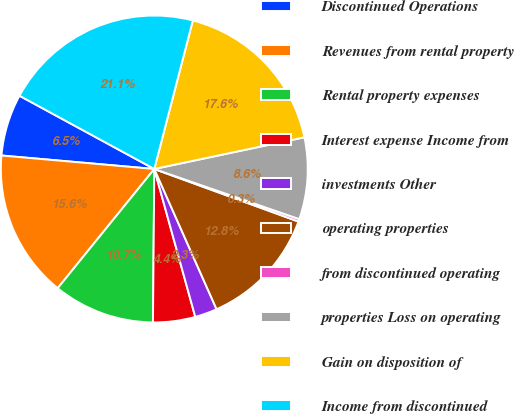<chart> <loc_0><loc_0><loc_500><loc_500><pie_chart><fcel>Discontinued Operations<fcel>Revenues from rental property<fcel>Rental property expenses<fcel>Interest expense Income from<fcel>investments Other<fcel>operating properties<fcel>from discontinued operating<fcel>properties Loss on operating<fcel>Gain on disposition of<fcel>Income from discontinued<nl><fcel>6.52%<fcel>15.56%<fcel>10.7%<fcel>4.44%<fcel>2.35%<fcel>12.78%<fcel>0.27%<fcel>8.61%<fcel>17.65%<fcel>21.12%<nl></chart> 